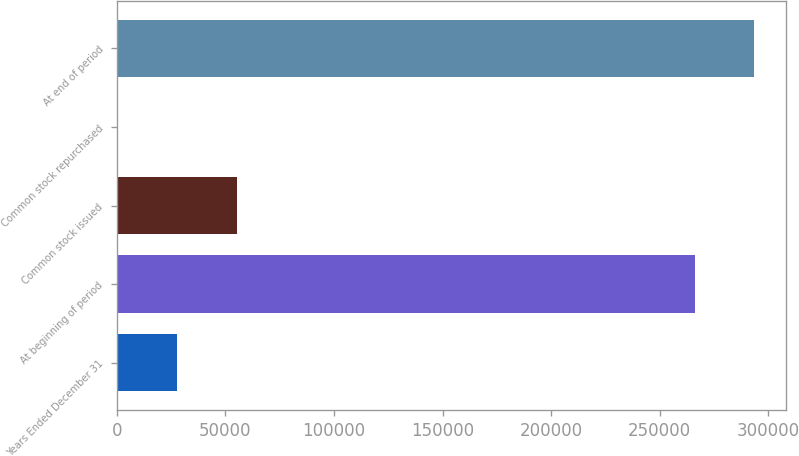Convert chart. <chart><loc_0><loc_0><loc_500><loc_500><bar_chart><fcel>Years Ended December 31<fcel>At beginning of period<fcel>Common stock issued<fcel>Common stock repurchased<fcel>At end of period<nl><fcel>27762.3<fcel>266137<fcel>55253.6<fcel>271<fcel>293628<nl></chart> 